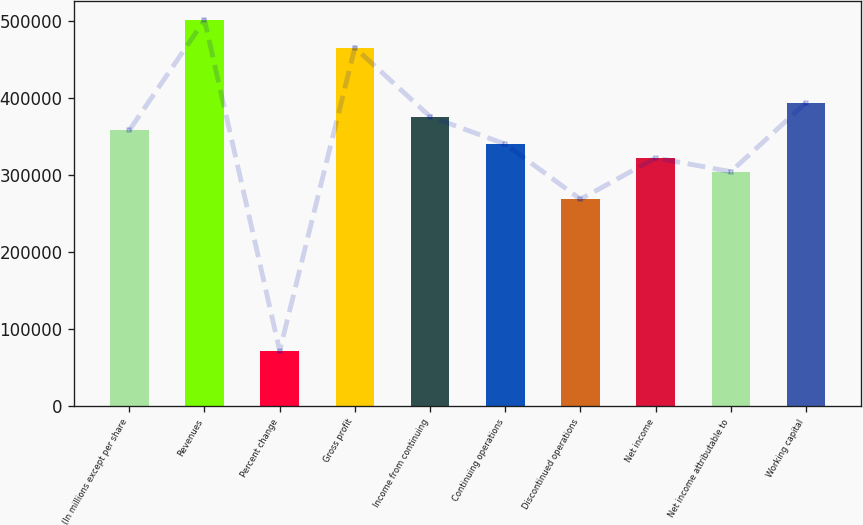<chart> <loc_0><loc_0><loc_500><loc_500><bar_chart><fcel>(In millions except per share<fcel>Revenues<fcel>Percent change<fcel>Gross profit<fcel>Income from continuing<fcel>Continuing operations<fcel>Discontinued operations<fcel>Net income<fcel>Net income attributable to<fcel>Working capital<nl><fcel>358089<fcel>501324<fcel>71618.6<fcel>465515<fcel>375993<fcel>340185<fcel>268567<fcel>322280<fcel>304376<fcel>393898<nl></chart> 